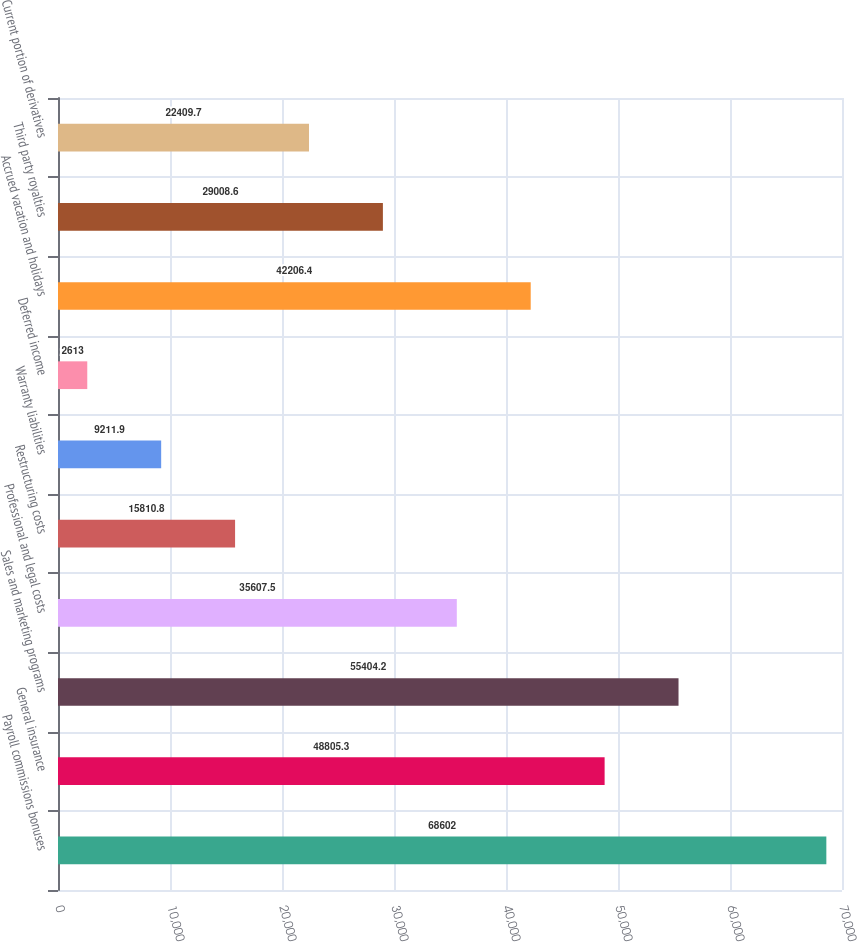<chart> <loc_0><loc_0><loc_500><loc_500><bar_chart><fcel>Payroll commissions bonuses<fcel>General insurance<fcel>Sales and marketing programs<fcel>Professional and legal costs<fcel>Restructuring costs<fcel>Warranty liabilities<fcel>Deferred income<fcel>Accrued vacation and holidays<fcel>Third party royalties<fcel>Current portion of derivatives<nl><fcel>68602<fcel>48805.3<fcel>55404.2<fcel>35607.5<fcel>15810.8<fcel>9211.9<fcel>2613<fcel>42206.4<fcel>29008.6<fcel>22409.7<nl></chart> 